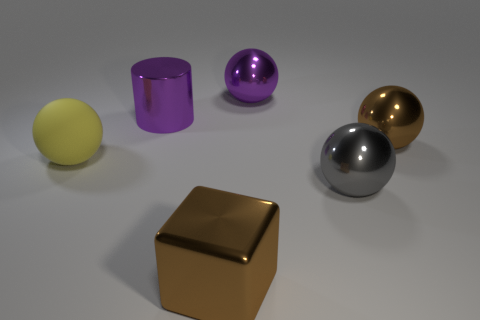Are the big yellow object and the brown ball made of the same material?
Your response must be concise. No. There is a big purple metal thing that is right of the brown thing in front of the large brown object that is to the right of the purple sphere; what is its shape?
Make the answer very short. Sphere. What is the big sphere that is both in front of the large brown metal ball and to the right of the matte sphere made of?
Offer a terse response. Metal. What is the color of the large sphere that is to the left of the big ball that is behind the metal ball that is right of the gray object?
Provide a short and direct response. Yellow. How many green objects are either metallic blocks or cylinders?
Your answer should be compact. 0. How many other objects are the same size as the brown shiny ball?
Give a very brief answer. 5. How many large metallic objects are there?
Give a very brief answer. 5. Is there any other thing that is the same shape as the gray thing?
Your response must be concise. Yes. Is the material of the big ball behind the metal cylinder the same as the big object that is to the left of the cylinder?
Offer a very short reply. No. What is the big purple ball made of?
Keep it short and to the point. Metal. 